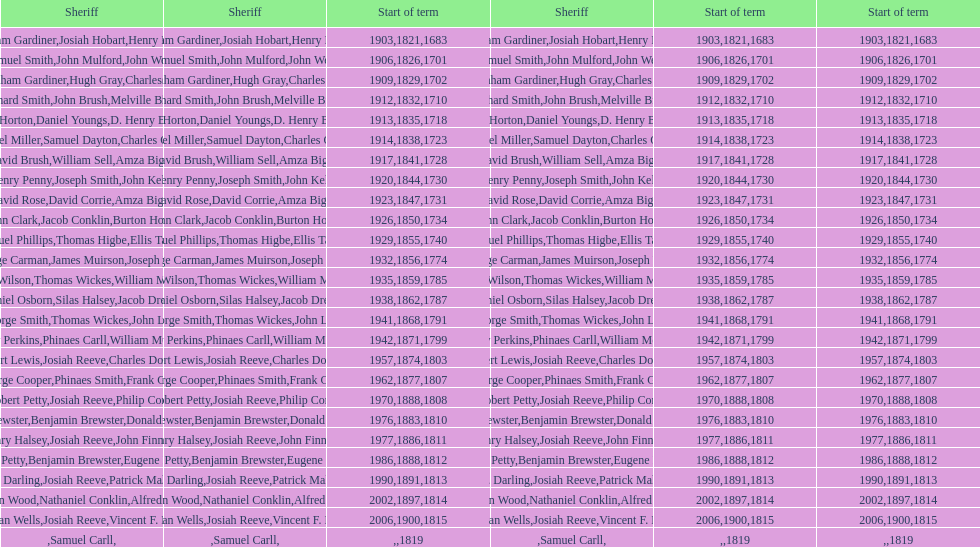When did benjamin brewster serve his second term? 1812. 